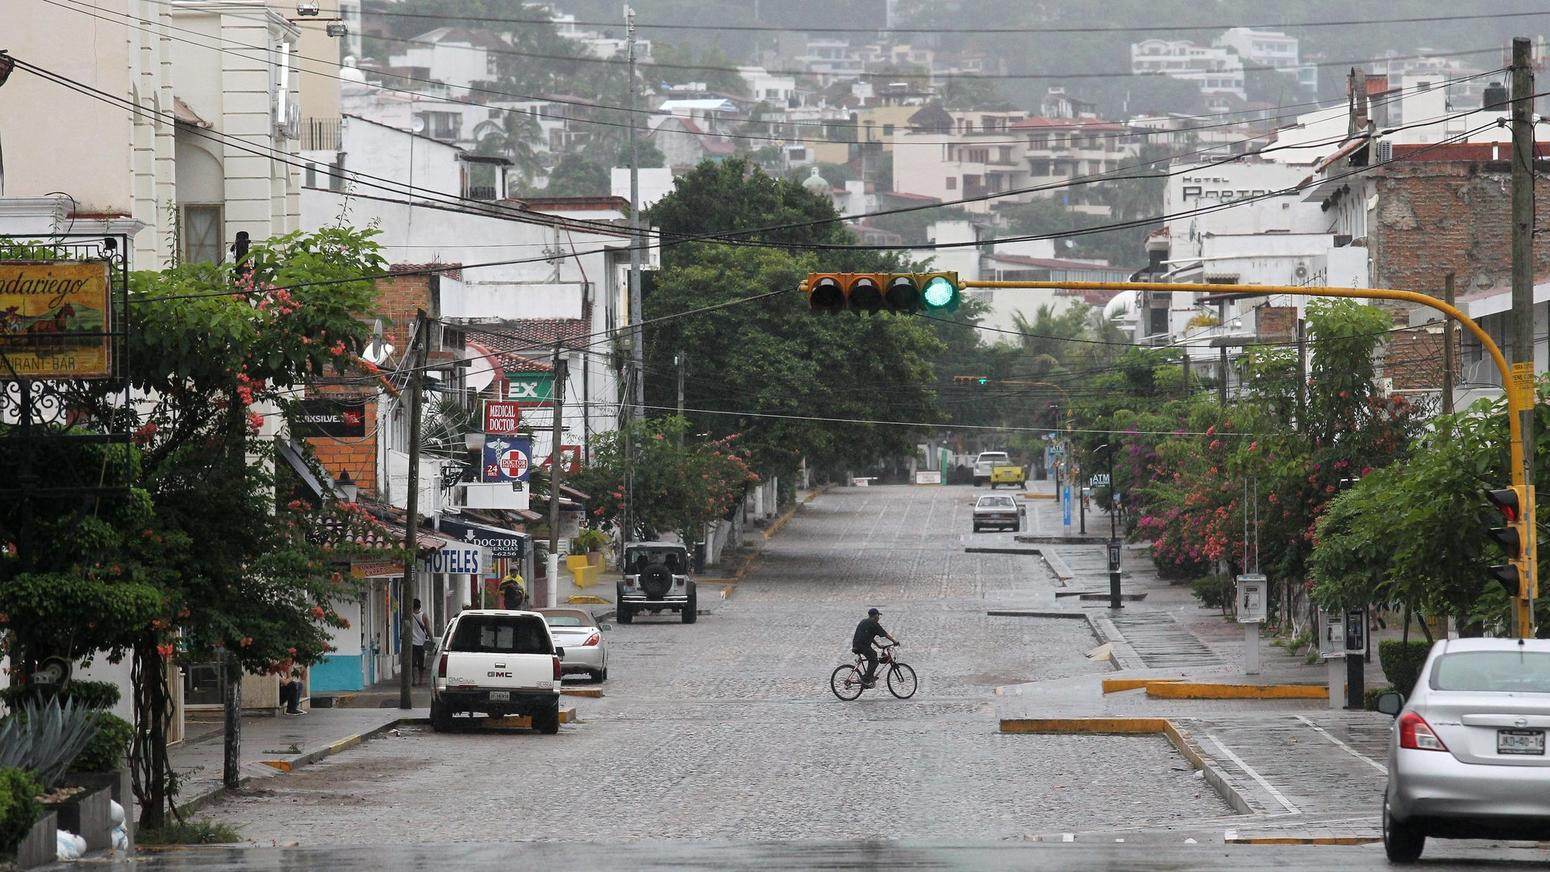Based on the visible signage, what types of services are available on this street, and how does the presence of these services inform us about the character of the neighborhood? The street offers a variety of services including hospitality, medical, and dining, as indicated by the signage for hotels, a medical center, and a bar. This suggests that the neighborhood caters to both local residents and visitors, potentially indicating a mixed-use area where commerce and daily living intersect. The variety of services within a short distance implies a neighborhood designed for accessibility and convenience. 